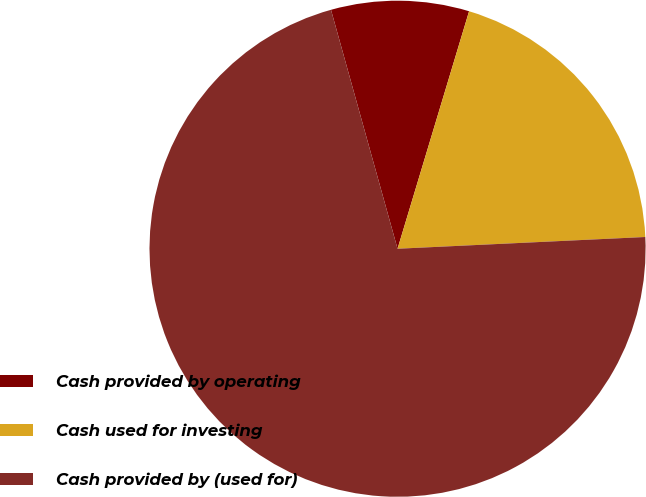Convert chart. <chart><loc_0><loc_0><loc_500><loc_500><pie_chart><fcel>Cash provided by operating<fcel>Cash used for investing<fcel>Cash provided by (used for)<nl><fcel>8.98%<fcel>19.59%<fcel>71.43%<nl></chart> 